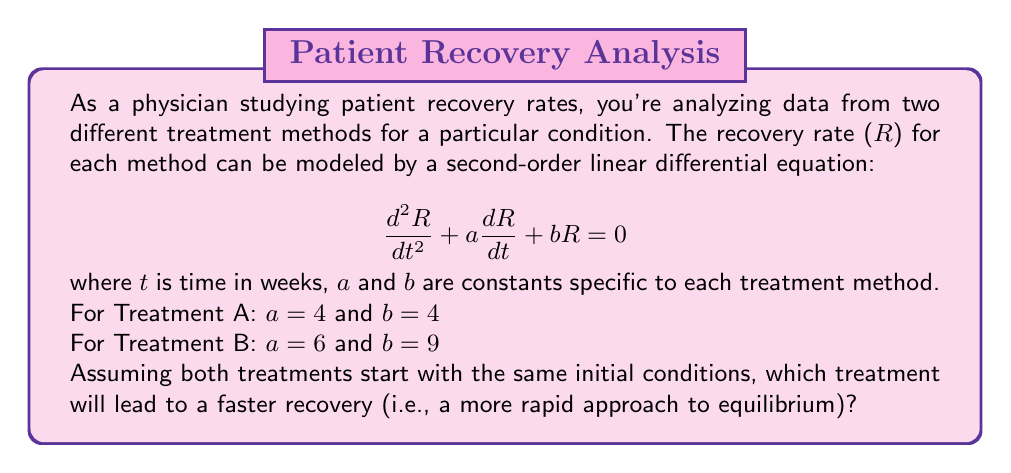Give your solution to this math problem. To determine which treatment leads to a faster recovery, we need to analyze the characteristic equation for each treatment's differential equation.

1. General form of the characteristic equation:
   $$r^2 + ar + b = 0$$

2. For Treatment A:
   $$r^2 + 4r + 4 = 0$$
   This is a perfect square: $(r + 2)^2 = 0$
   The roots are: $r_1 = r_2 = -2$

3. For Treatment B:
   $$r^2 + 6r + 9 = 0$$
   This is also a perfect square: $(r + 3)^2 = 0$
   The roots are: $r_1 = r_2 = -3$

4. The general solution for each treatment will be of the form:
   $$R(t) = (C_1 + C_2t)e^{rt}$$
   where $r$ is the repeated root, and $C_1$ and $C_2$ are constants determined by initial conditions.

5. The rate of approach to equilibrium is determined by the real part of the roots. The more negative the real part, the faster the approach to equilibrium.

6. Comparing the roots:
   Treatment A: $r = -2$
   Treatment B: $r = -3$

Since the root for Treatment B is more negative, it will lead to a faster approach to equilibrium, and thus a faster recovery.
Answer: Treatment B will lead to a faster recovery. 